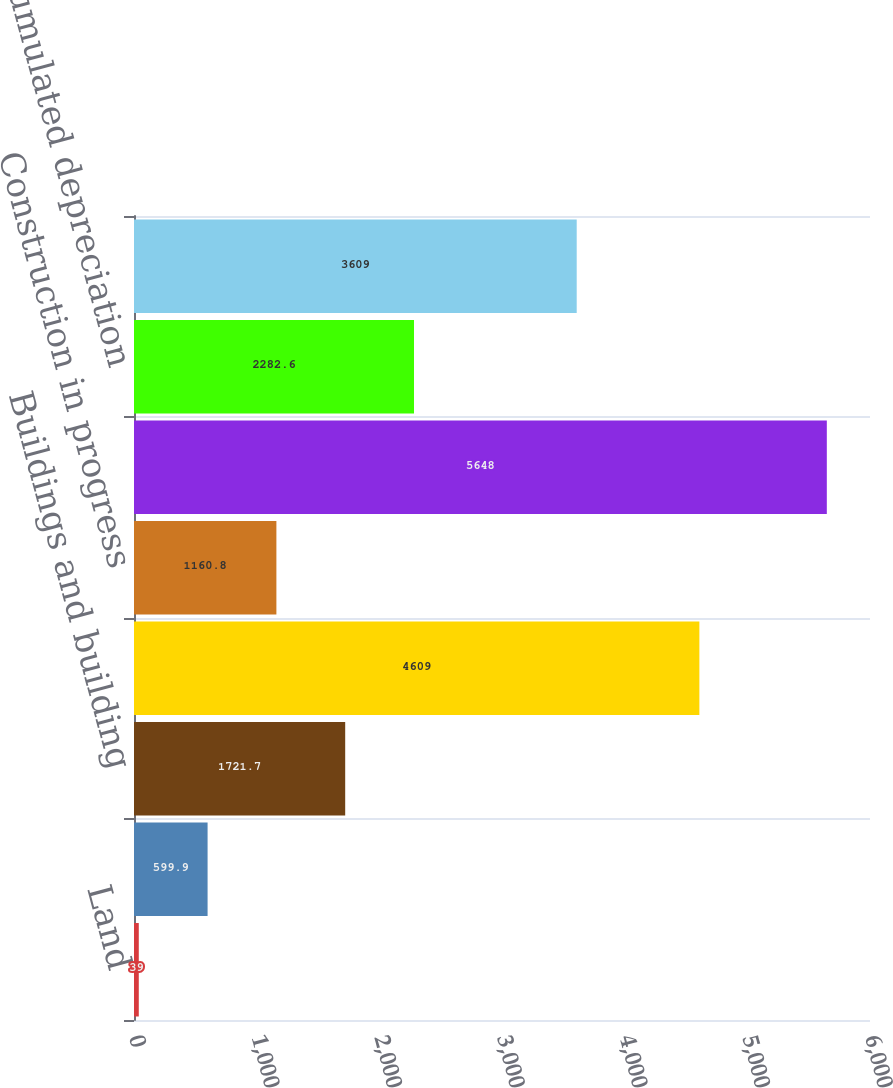Convert chart to OTSL. <chart><loc_0><loc_0><loc_500><loc_500><bar_chart><fcel>Land<fcel>Land improvements<fcel>Buildings and building<fcel>Machinery and equipment<fcel>Construction in progress<fcel>Gross asset value<fcel>Accumulated depreciation<fcel>Net book value<nl><fcel>39<fcel>599.9<fcel>1721.7<fcel>4609<fcel>1160.8<fcel>5648<fcel>2282.6<fcel>3609<nl></chart> 